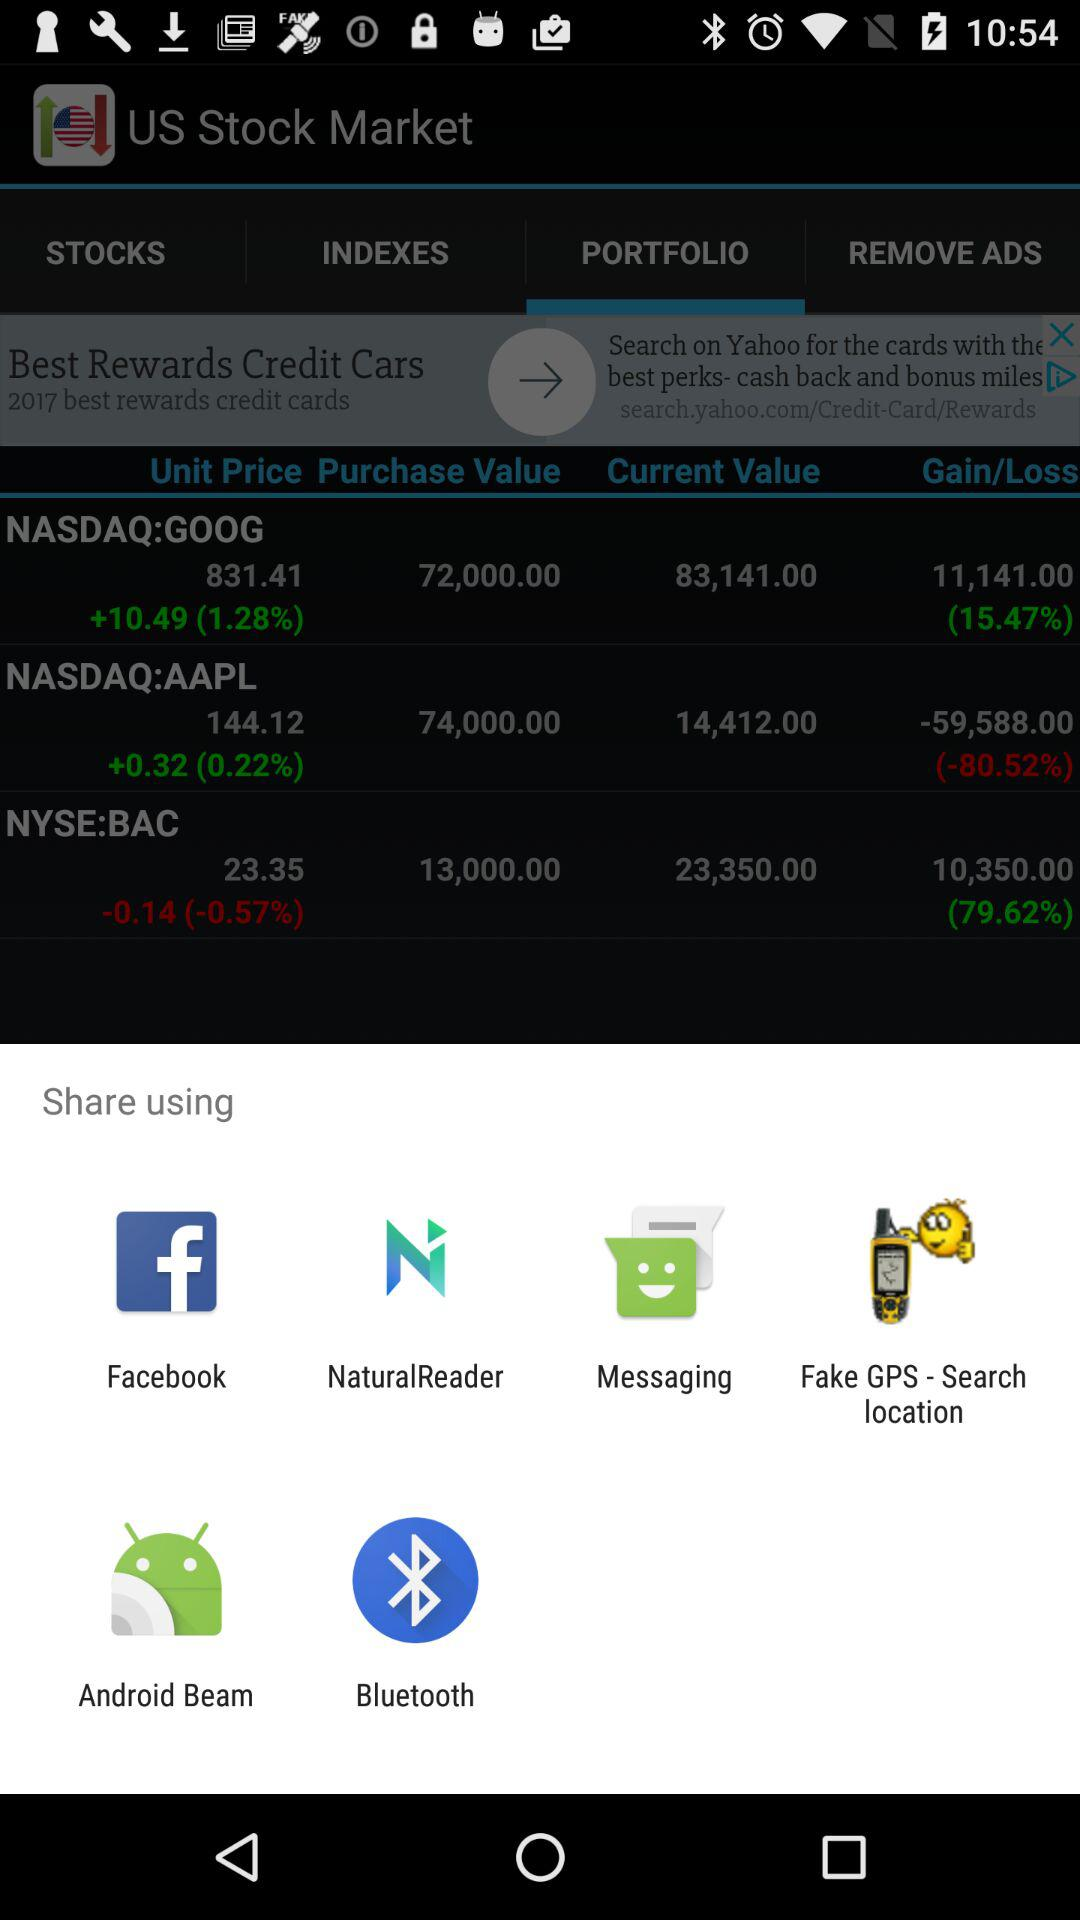How many items are in "STOCKS"?
When the provided information is insufficient, respond with <no answer>. <no answer> 